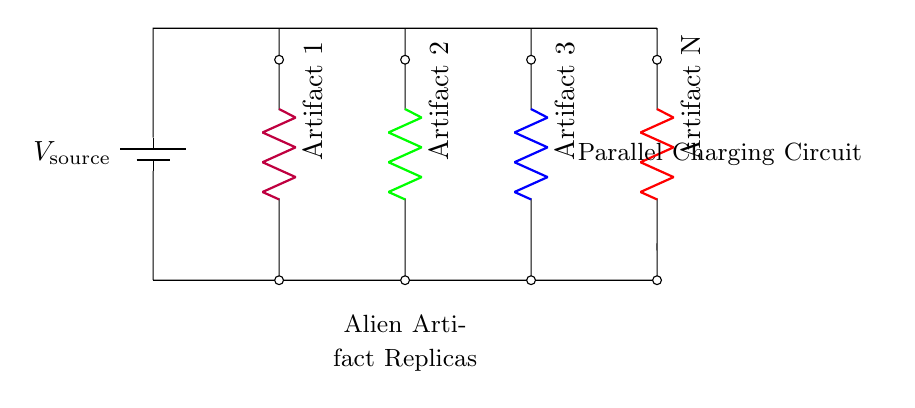What is the total voltage supplied to the circuit? The total voltage supplied is equal to the voltage of the source, which is represented by \( V_{\text{source}} \) in the circuit diagram.
Answer: V_source How many alien artifacts are connected in the circuit? There are four artifacts in the circuit, indicated by the four-dimensional resistors labeled "Artifact 1," "Artifact 2," "Artifact 3," and "Artifact N."
Answer: Four What type of circuit is this? This circuit is a parallel circuit setup, as indicated by the multiple branches connected directly across the voltage source, allowing each artifact to be charged independently.
Answer: Parallel What is the function of the individual resistors in the circuit? The individual resistors represent the alien artifacts, providing separate paths for current flow while allowing the voltage across each artifact to remain the same as the source voltage.
Answer: Charging If one artifact has a higher resistance, how does it affect the others? It does not affect the others; in a parallel circuit, each branch operates independently. Therefore, the current through one branch does not change the voltage or current in other branches.
Answer: Independently How is the current distributed among the artifacts? The current is distributed based on the resistance of each artifact; lower resistance artifacts draw more current, while higher resistance ones draw less, maintaining the same voltage across all.
Answer: Varies with resistance 